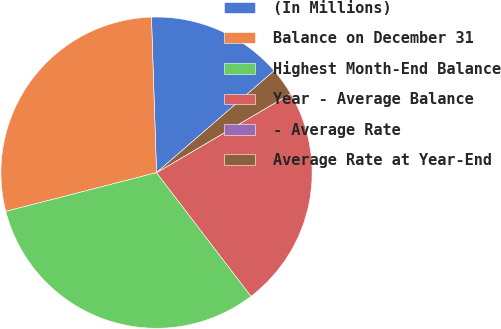Convert chart to OTSL. <chart><loc_0><loc_0><loc_500><loc_500><pie_chart><fcel>(In Millions)<fcel>Balance on December 31<fcel>Highest Month-End Balance<fcel>Year - Average Balance<fcel>- Average Rate<fcel>Average Rate at Year-End<nl><fcel>14.16%<fcel>28.49%<fcel>31.38%<fcel>23.08%<fcel>0.0%<fcel>2.9%<nl></chart> 